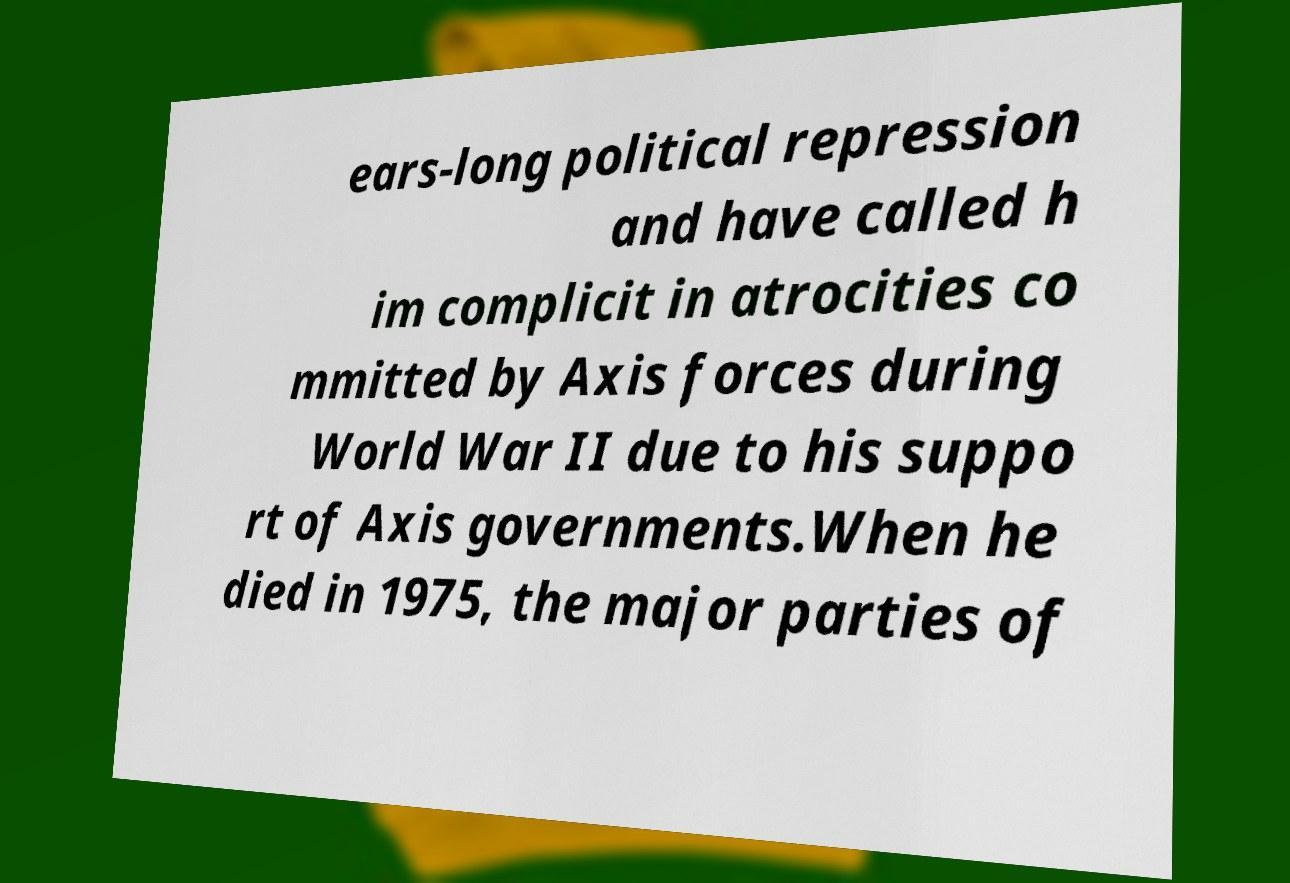Could you assist in decoding the text presented in this image and type it out clearly? ears-long political repression and have called h im complicit in atrocities co mmitted by Axis forces during World War II due to his suppo rt of Axis governments.When he died in 1975, the major parties of 